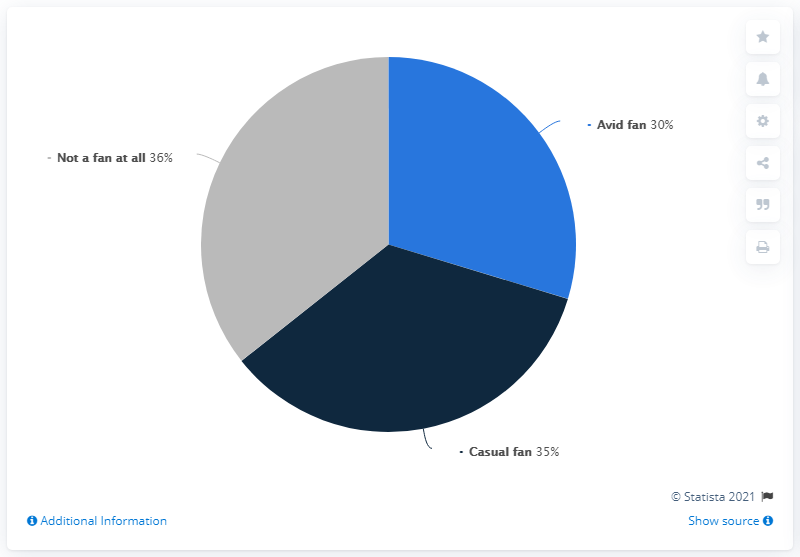What does the pie chart in the image represent? The pie chart represents the distribution of fans based on their level of interest. It appears to be a survey result where 30% are 'Avid fans', 35% are 'Casual fans', and 36% are 'Not a fan at all'. How could this information be useful? This data can be particularly useful for marketers and product managers to understand their audience's dedication and tailor their strategies accordingly. For example, content for avid fans can be more detailed and niche, while general content can appeal to casual fans. 